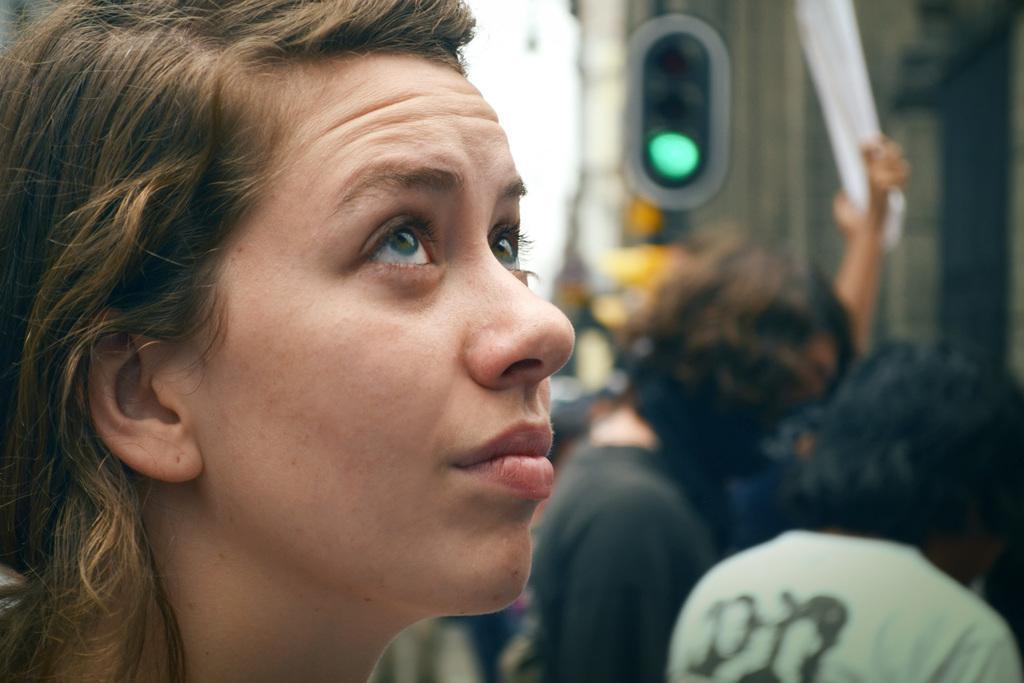How would you summarize this image in a sentence or two? In this image there is a girl, beside the girl, there are a few people standing. The background is blurred. 